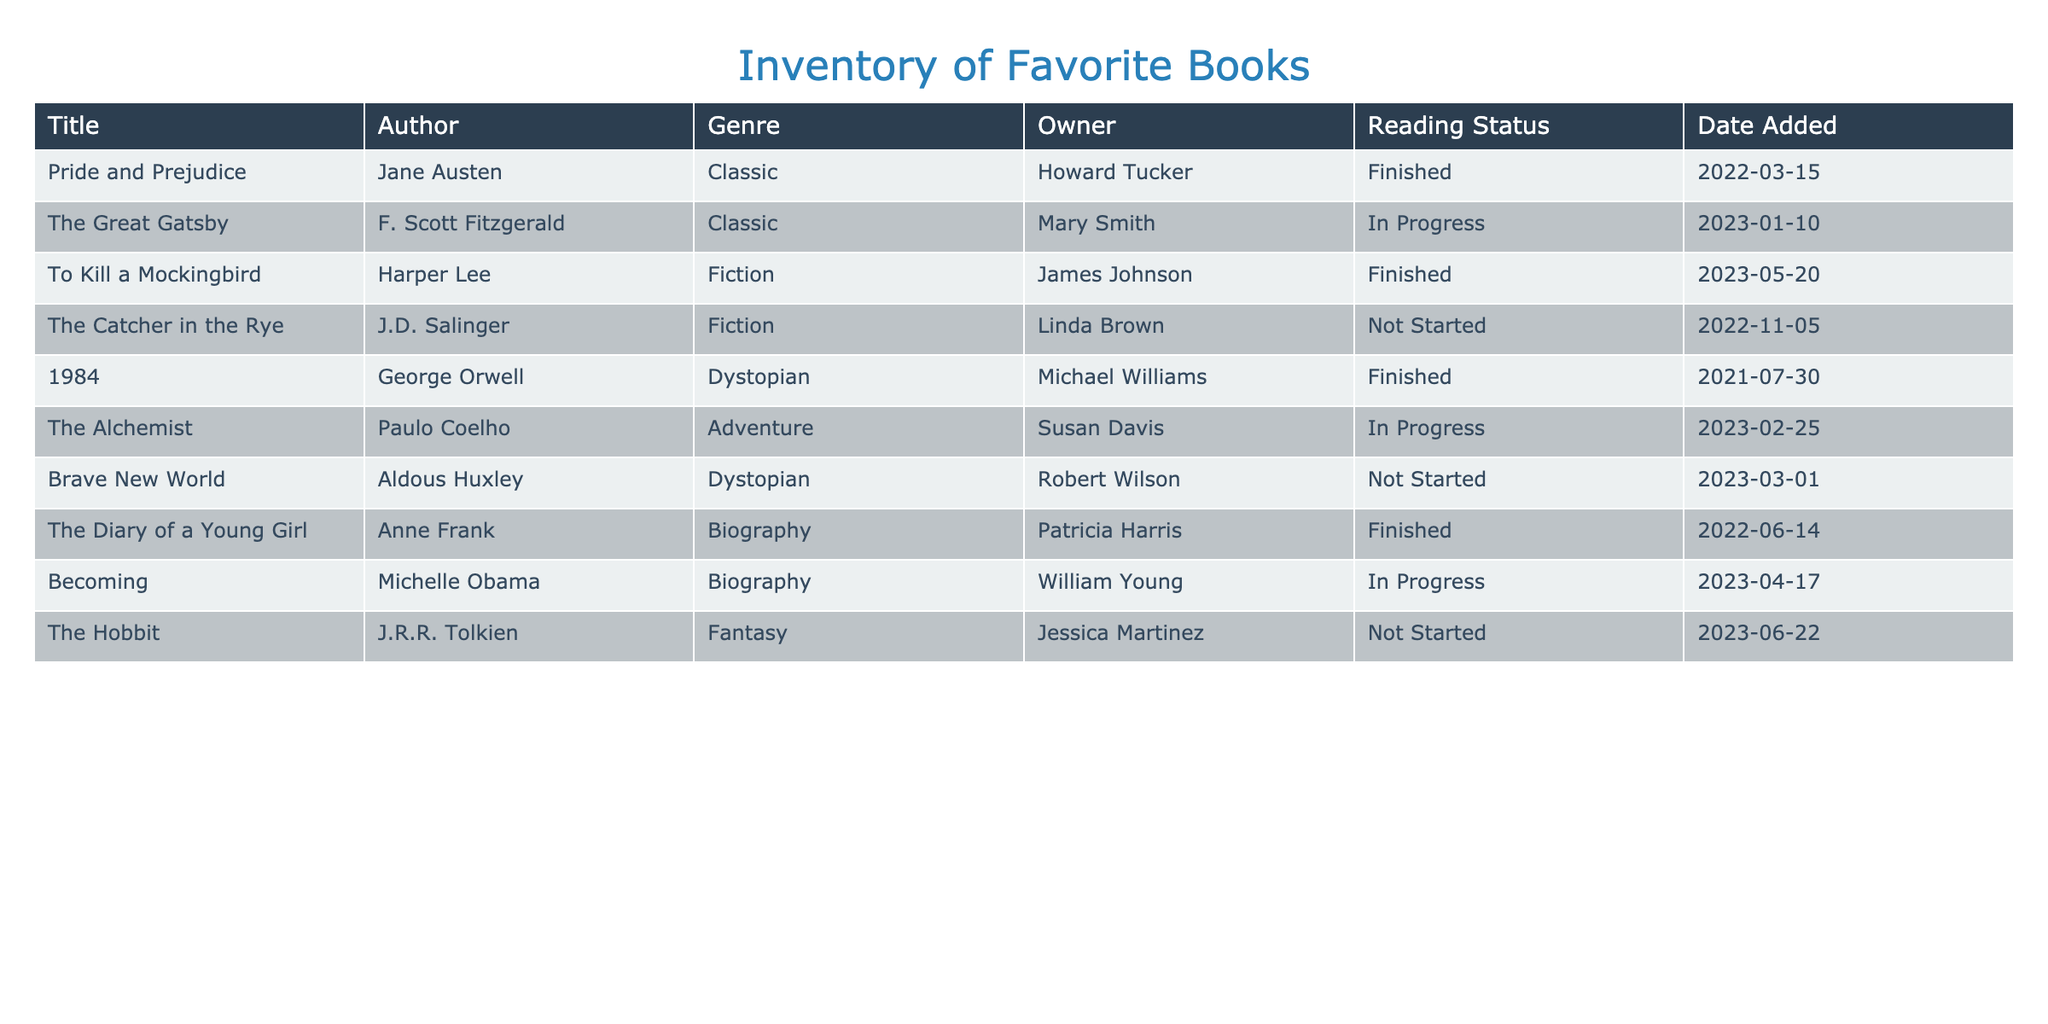What is the title of the book that Howard Tucker owns? In the "Owner" column, we look for the row where "Owner" is "Howard Tucker," which corresponds to "Pride and Prejudice" in the "Title" column.
Answer: Pride and Prejudice How many books are currently marked as 'In Progress'? We count the instances in the "Reading Status" column where the status is "In Progress." There are two such books: "The Great Gatsby" and "The Alchemist."
Answer: 2 Is there a book titled 'The Catcher in the Rye'? We search through the "Title" column for "The Catcher in the Rye." It exists, confirming that this specific title is present in the inventory.
Answer: Yes What is the genre of the book '1984'? We locate the book titled "1984" in the "Title" column and then move to the corresponding row in the "Genre" column to find its genre, which is "Dystopian."
Answer: Dystopian Which owner has the most books marked as 'Not Started'? We examine the "Owner" column for books marked as "Not Started." "Linda Brown" owns one ("The Catcher in the Rye"), "Robert Wilson" owns one ("Brave New World"), and "Jessica Martinez" owns one ("The Hobbit"). Each owner has the same number, so no single owner has more.
Answer: All owners have one What percentage of the books are in the 'Finished' status? There are 10 total books. Out of these, 4 are marked as "Finished": "Pride and Prejudice," "To Kill a Mockingbird," "1984," and "The Diary of a Young Girl." The percentage calculation is (4/10) * 100 = 40%.
Answer: 40% Which author wrote the book that was added most recently? Checking the "Date Added" column, the most recent date is "2023-06-22," corresponding to "The Hobbit" by "J.R.R. Tolkien."
Answer: J.R.R. Tolkien How many different genres are represented in the inventory? We list the genres: Classic, Fiction, Dystopian, Adventure, Biography, and Fantasy. There are 6 unique genres when we count them without repetition.
Answer: 6 What is the only book that has 'Adventure' as its genre? We search the "Genre" column for "Adventure," which corresponds to the title "The Alchemist" in the "Title" column. There is only one match.
Answer: The Alchemist 